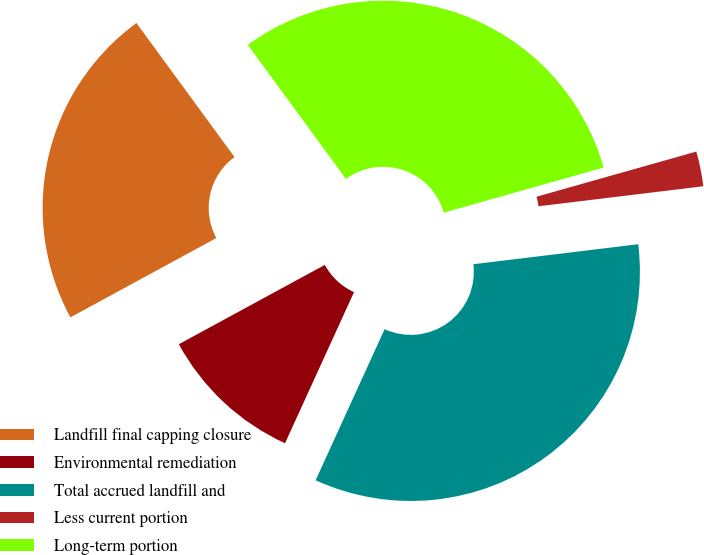Convert chart. <chart><loc_0><loc_0><loc_500><loc_500><pie_chart><fcel>Landfill final capping closure<fcel>Environmental remediation<fcel>Total accrued landfill and<fcel>Less current portion<fcel>Long-term portion<nl><fcel>22.87%<fcel>10.26%<fcel>33.74%<fcel>2.46%<fcel>30.67%<nl></chart> 